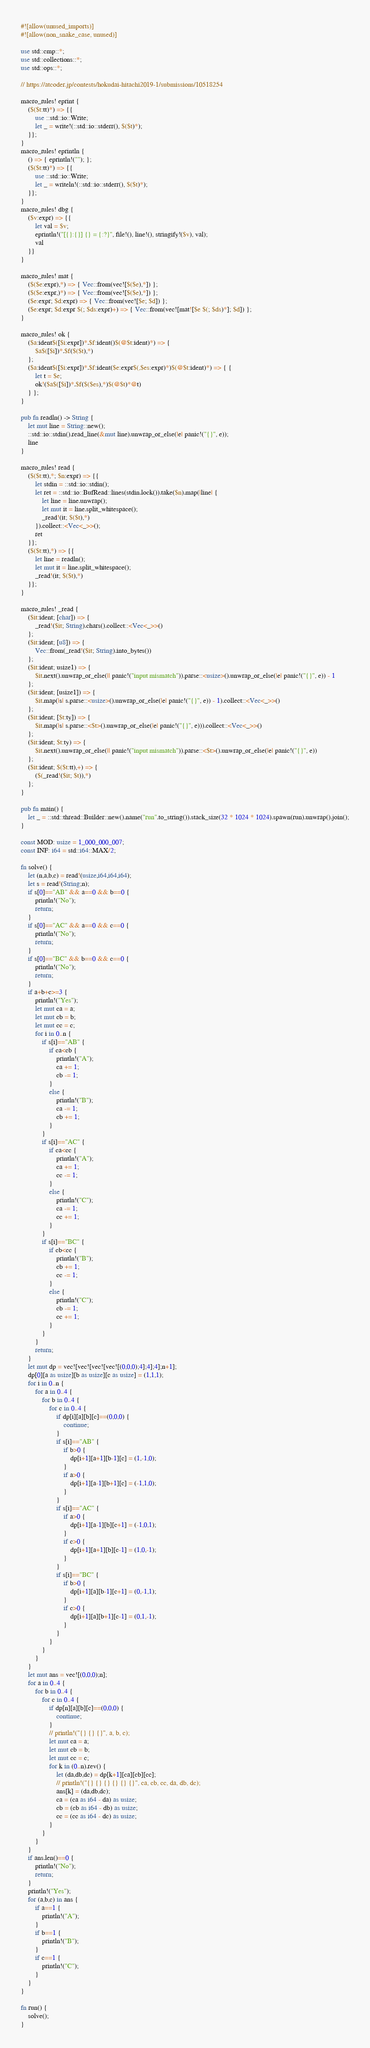Convert code to text. <code><loc_0><loc_0><loc_500><loc_500><_Rust_>#![allow(unused_imports)]
#![allow(non_snake_case, unused)]

use std::cmp::*;
use std::collections::*;
use std::ops::*;

// https://atcoder.jp/contests/hokudai-hitachi2019-1/submissions/10518254

macro_rules! eprint {
	($($t:tt)*) => {{
		use ::std::io::Write;
		let _ = write!(::std::io::stderr(), $($t)*);
	}};
}
macro_rules! eprintln {
	() => { eprintln!(""); };
	($($t:tt)*) => {{
		use ::std::io::Write;
		let _ = writeln!(::std::io::stderr(), $($t)*);
	}};
}
macro_rules! dbg {
	($v:expr) => {{
		let val = $v;
		eprintln!("[{}:{}] {} = {:?}", file!(), line!(), stringify!($v), val);
		val
	}}
}

macro_rules! mat {
	($($e:expr),*) => { Vec::from(vec![$($e),*]) };
	($($e:expr,)*) => { Vec::from(vec![$($e),*]) };
	($e:expr; $d:expr) => { Vec::from(vec![$e; $d]) };
	($e:expr; $d:expr $(; $ds:expr)+) => { Vec::from(vec![mat![$e $(; $ds)*]; $d]) };
}

macro_rules! ok {
	($a:ident$([$i:expr])*.$f:ident()$(@$t:ident)*) => {
		$a$([$i])*.$f($($t),*)
	};
	($a:ident$([$i:expr])*.$f:ident($e:expr$(,$es:expr)*)$(@$t:ident)*) => { {
		let t = $e;
		ok!($a$([$i])*.$f($($es),*)$(@$t)*@t)
	} };
}

pub fn readln() -> String {
	let mut line = String::new();
	::std::io::stdin().read_line(&mut line).unwrap_or_else(|e| panic!("{}", e));
	line
}

macro_rules! read {
	($($t:tt),*; $n:expr) => {{
		let stdin = ::std::io::stdin();
		let ret = ::std::io::BufRead::lines(stdin.lock()).take($n).map(|line| {
			let line = line.unwrap();
			let mut it = line.split_whitespace();
			_read!(it; $($t),*)
		}).collect::<Vec<_>>();
		ret
	}};
	($($t:tt),*) => {{
		let line = readln();
		let mut it = line.split_whitespace();
		_read!(it; $($t),*)
	}};
}

macro_rules! _read {
	($it:ident; [char]) => {
		_read!($it; String).chars().collect::<Vec<_>>()
	};
	($it:ident; [u8]) => {
		Vec::from(_read!($it; String).into_bytes())
	};
	($it:ident; usize1) => {
		$it.next().unwrap_or_else(|| panic!("input mismatch")).parse::<usize>().unwrap_or_else(|e| panic!("{}", e)) - 1
	};
	($it:ident; [usize1]) => {
		$it.map(|s| s.parse::<usize>().unwrap_or_else(|e| panic!("{}", e)) - 1).collect::<Vec<_>>()
	};
	($it:ident; [$t:ty]) => {
		$it.map(|s| s.parse::<$t>().unwrap_or_else(|e| panic!("{}", e))).collect::<Vec<_>>()
	};
	($it:ident; $t:ty) => {
		$it.next().unwrap_or_else(|| panic!("input mismatch")).parse::<$t>().unwrap_or_else(|e| panic!("{}", e))
	};
	($it:ident; $($t:tt),+) => {
		($(_read!($it; $t)),*)
	};
}

pub fn main() {
	let _ = ::std::thread::Builder::new().name("run".to_string()).stack_size(32 * 1024 * 1024).spawn(run).unwrap().join();
}

const MOD: usize = 1_000_000_007;
const INF: i64 = std::i64::MAX/2;

fn solve() {
    let (n,a,b,c) = read!(usize,i64,i64,i64);
    let s = read!(String;n);
    if s[0]=="AB" && a==0 && b==0 {
        println!("No");
        return;
    }
    if s[0]=="AC" && a==0 && c==0 {
        println!("No");
        return;
    }
    if s[0]=="BC" && b==0 && c==0 {
        println!("No");
        return;
    }
    if a+b+c>=3 {
        println!("Yes");
        let mut ca = a;
        let mut cb = b;
        let mut cc = c;
        for i in 0..n {
            if s[i]=="AB" {
                if ca<cb {
                    println!("A");
                    ca += 1;
                    cb -= 1;
                }
                else {
                    println!("B");
                    ca -= 1;
                    cb += 1;
                }
            }
            if s[i]=="AC" {
                if ca<cc {
                    println!("A");
                    ca += 1;
                    cc -= 1;
                }
                else {
                    println!("C");
                    ca -= 1;
                    cc += 1;
                }
            }
            if s[i]=="BC" {
                if cb<cc {
                    println!("B");
                    cb += 1;
                    cc -= 1;
                }
                else {
                    println!("C");
                    cb -= 1;
                    cc += 1;
                }
            }
        }
        return;
    }
    let mut dp = vec![vec![vec![vec![(0,0,0);4];4];4];n+1];
    dp[0][a as usize][b as usize][c as usize] = (1,1,1);
    for i in 0..n {
        for a in 0..4 {
            for b in 0..4 {
                for c in 0..4 {
                    if dp[i][a][b][c]==(0,0,0) {
                        continue;
                    }
                    if s[i]=="AB" {
                        if b>0 {
                            dp[i+1][a+1][b-1][c] = (1,-1,0);
                        }
                        if a>0 {
                            dp[i+1][a-1][b+1][c] = (-1,1,0);
                        }
                    }
                    if s[i]=="AC" {
                        if a>0 {
                            dp[i+1][a-1][b][c+1] = (-1,0,1);
                        }
                        if c>0 {
                            dp[i+1][a+1][b][c-1] = (1,0,-1);
                        }
                    }
                    if s[i]=="BC" {
                        if b>0 {
                            dp[i+1][a][b-1][c+1] = (0,-1,1);
                        }
                        if c>0 {
                            dp[i+1][a][b+1][c-1] = (0,1,-1);
                        }
                    }
                }
            }
        }
    }
    let mut ans = vec![(0,0,0);n];
    for a in 0..4 {
        for b in 0..4 {
            for c in 0..4 {
                if dp[n][a][b][c]==(0,0,0) {
                    continue;
                }
                // println!("{} {} {}", a, b, c);
                let mut ca = a;
                let mut cb = b;
                let mut cc = c;
                for k in (0..n).rev() {
                    let (da,db,dc) = dp[k+1][ca][cb][cc];
                    // println!("{} {} {} {} {} {}", ca, cb, cc, da, db, dc);
                    ans[k] = (da,db,dc);
                    ca = (ca as i64 - da) as usize;
                    cb = (cb as i64 - db) as usize;
                    cc = (cc as i64 - dc) as usize;
                }
            }
        }
    }
    if ans.len()==0 {
        println!("No");
        return;
    }
    println!("Yes");
    for (a,b,c) in ans {
        if a==1 {
            println!("A");
        }
        if b==1 {
            println!("B");
        }
        if c==1 {
            println!("C");
        }
    }
}

fn run() {
    solve();
}
</code> 